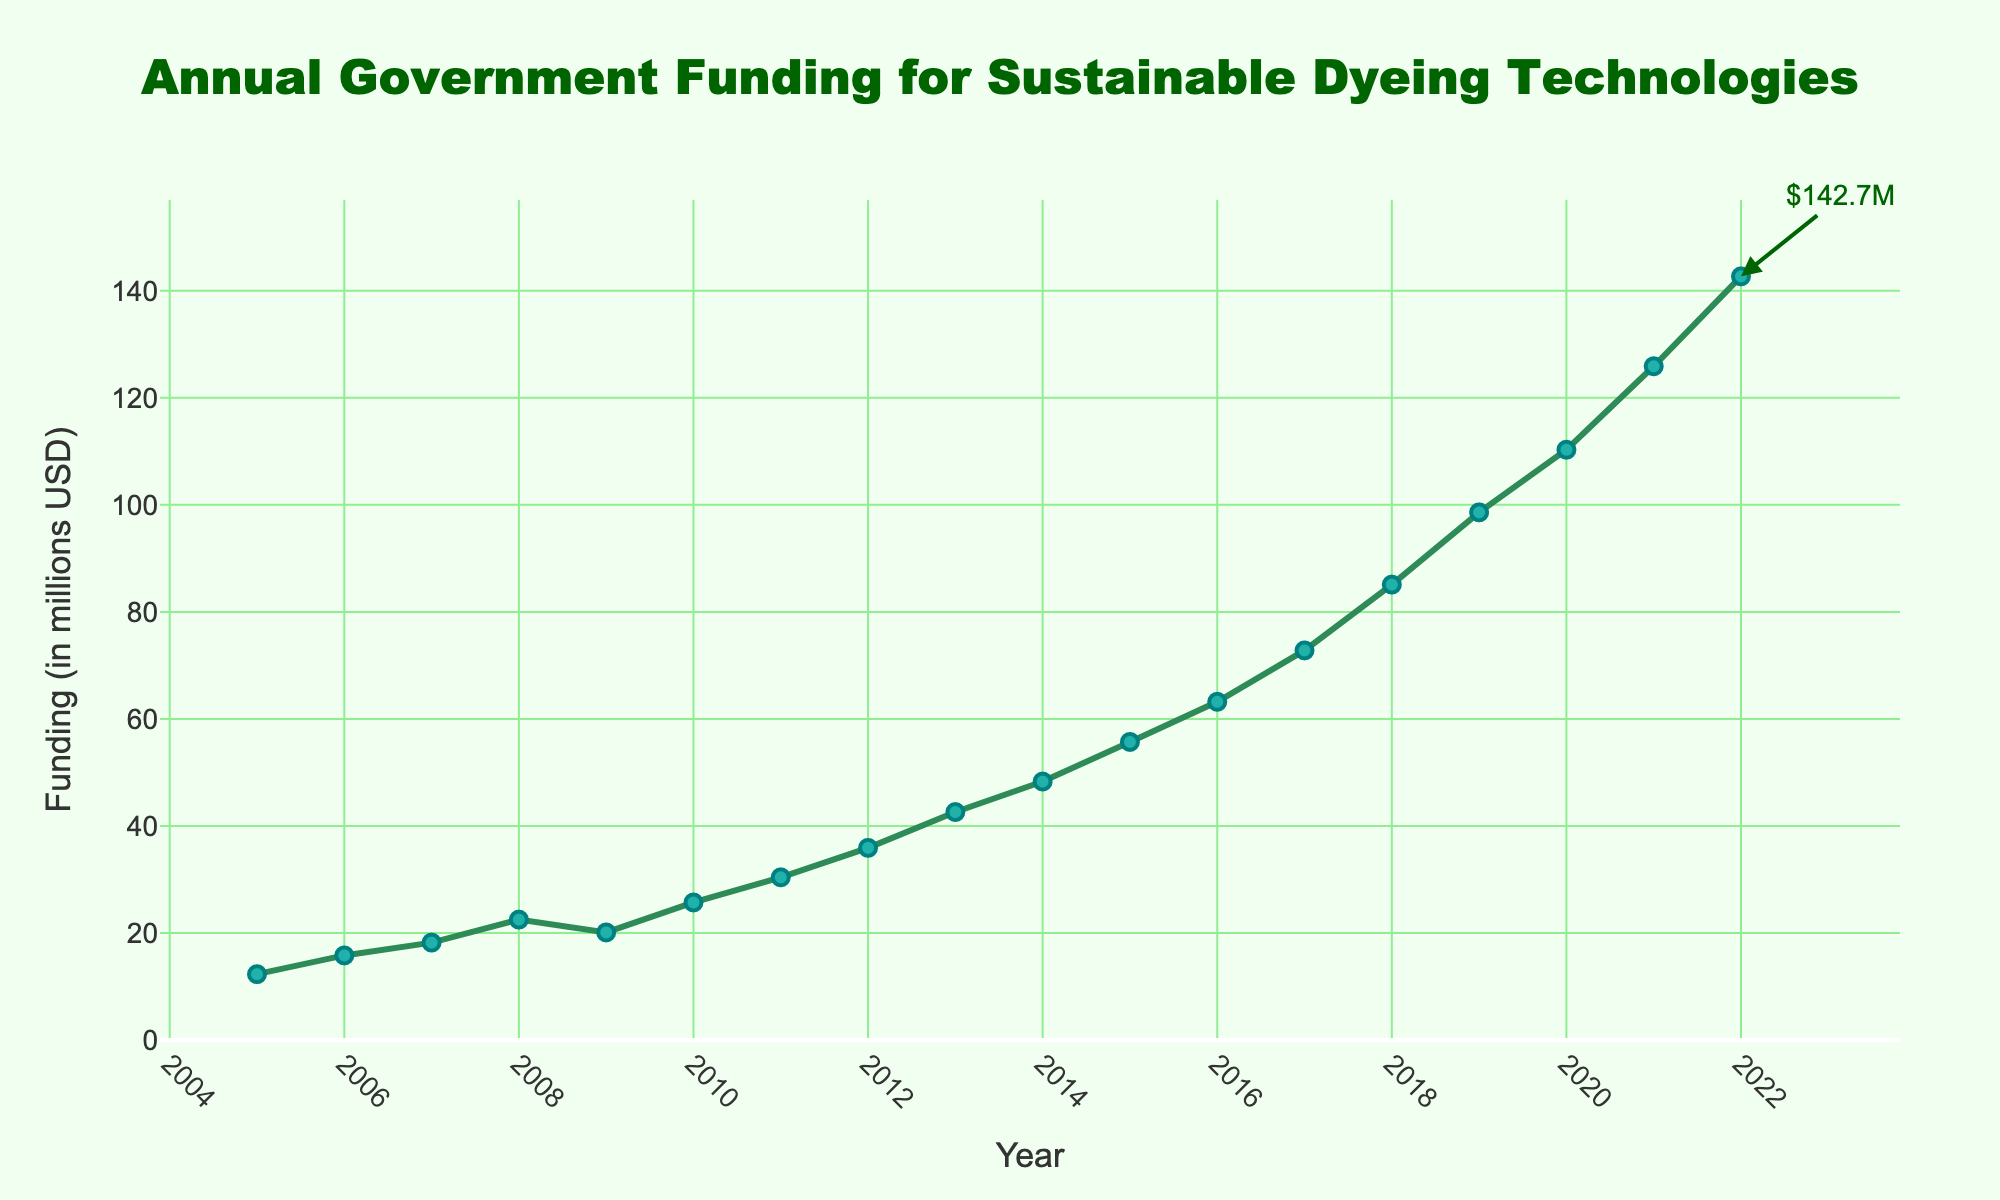What's the year with the highest government funding? The highest funding point on the chart is marked with an annotation. The annotation points to the last data point in the time series. By checking the x-axis, we see that this corresponds to the year 2022.
Answer: 2022 What was the approximate funding in 2010? To find the funding for 2010, we look at the point where the year 2010 aligns on the x-axis. The corresponding y-value for this point is around 25.7 million USD.
Answer: 25.7 million USD How much did the funding increase from 2005 to 2022? To find the increase, subtract the funding in 2005 from the funding in 2022: 142.7 million USD - 12.3 million USD = 130.4 million USD.
Answer: 130.4 million USD Which year had a funding lower than the funding in 2021? By examining the chart, any year before and including 2021 had lower funding compared to 2021. Specifically, every year from 2005 to 2020 had lower funding than 125.9 million USD (the funding in 2021).
Answer: 2005 to 2020 What is the average funding from 2015 to 2020? To find the average, sum the funding amounts from 2015 to 2020 and divide by the number of years. (55.7 + 63.2 + 72.8 + 85.1 + 98.6 + 110.3) million USD / 6 years = 485.7 million USD / 6 = 80.95 million USD.
Answer: 80.95 million USD How did the funding change between 2008 and 2009? To determine the change, subtract the 2008 funding from the 2009 funding: 20.1 million USD - 22.5 million USD = -2.4 million USD, indicating a decrease.
Answer: Decreased by 2.4 million USD Which color represents the yearly funding line in the chart? The chart uses a green-colored line to represent yearly funding.
Answer: Green Was there consistent growth over the years, and if not, where did it change? Examining the plot, the growth was generally consistent except between 2008 and 2009, where there was a slight dip.
Answer: Yes, except between 2008 and 2009 What is the ratio of the funding in 2022 to the funding in 2005? To find the ratio, divide the funding in 2022 by the funding in 2005: 142.7 million USD / 12.3 million USD ≈ 11.6.
Answer: 11.6 What is the average annual increase in funding from 2010 to 2015? Calculate the increase for each year, sum them up and divide by the number of years. ((30.4-25.7) + (35.9-30.4) + (42.6-35.9) + (48.3-42.6) + (55.7-48.3)) million USD divided by 5 years ≈ 6.3 million USD/year.
Answer: 6.3 million USD/year 